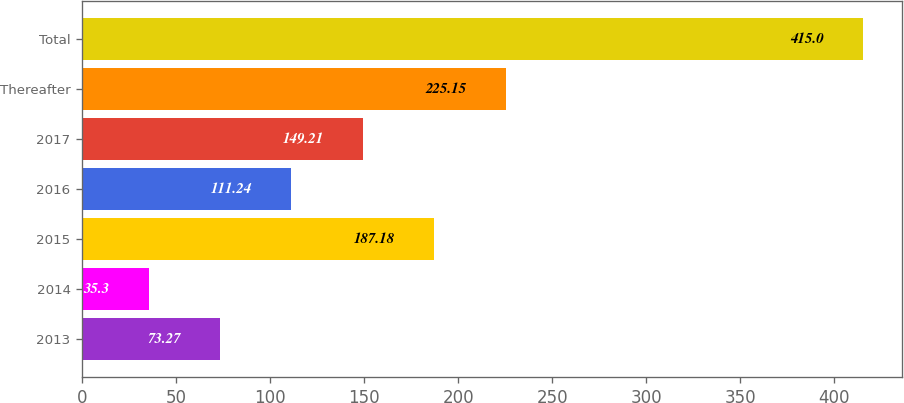Convert chart. <chart><loc_0><loc_0><loc_500><loc_500><bar_chart><fcel>2013<fcel>2014<fcel>2015<fcel>2016<fcel>2017<fcel>Thereafter<fcel>Total<nl><fcel>73.27<fcel>35.3<fcel>187.18<fcel>111.24<fcel>149.21<fcel>225.15<fcel>415<nl></chart> 